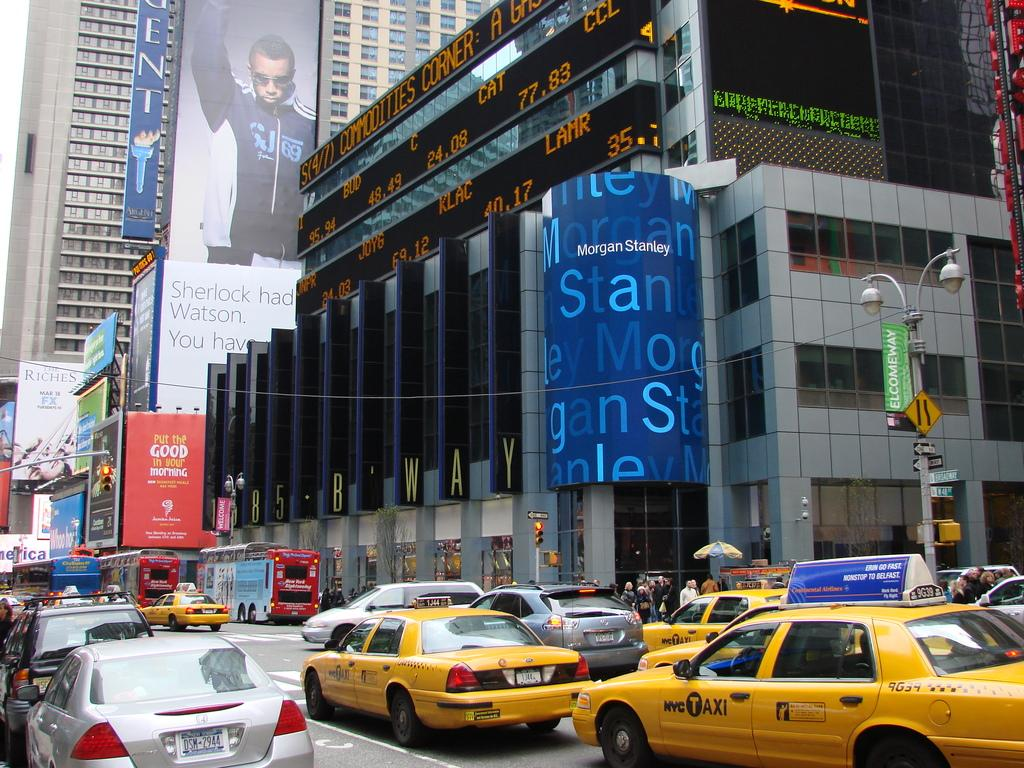<image>
Write a terse but informative summary of the picture. Many NYC Taxis drive down the street under a large Morgan Stanley blue sign. 